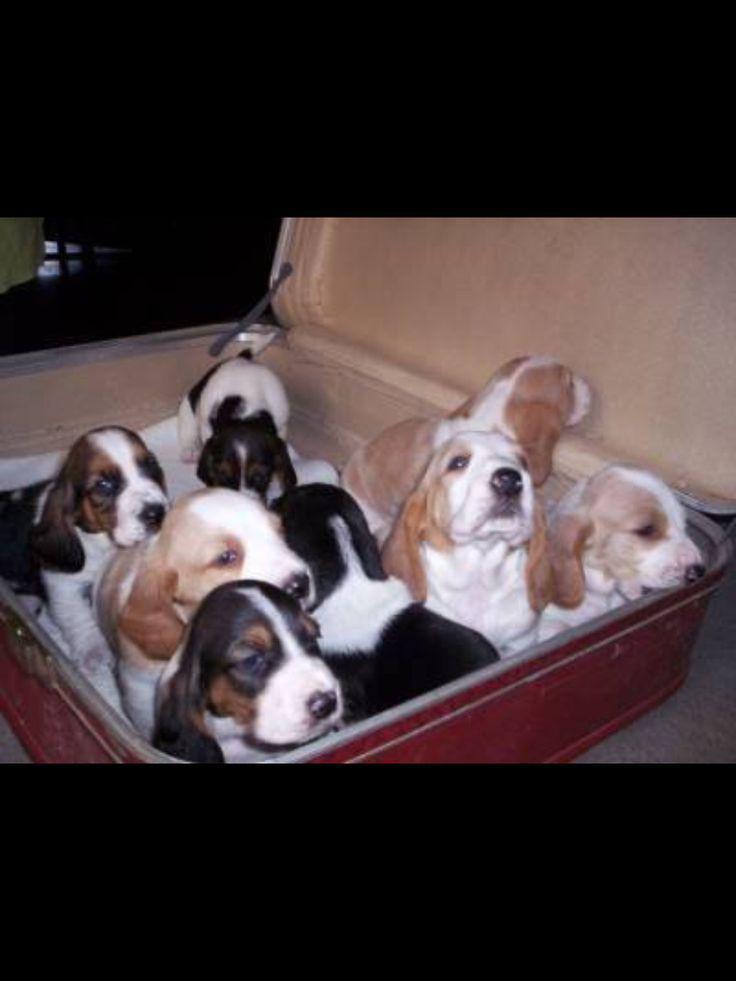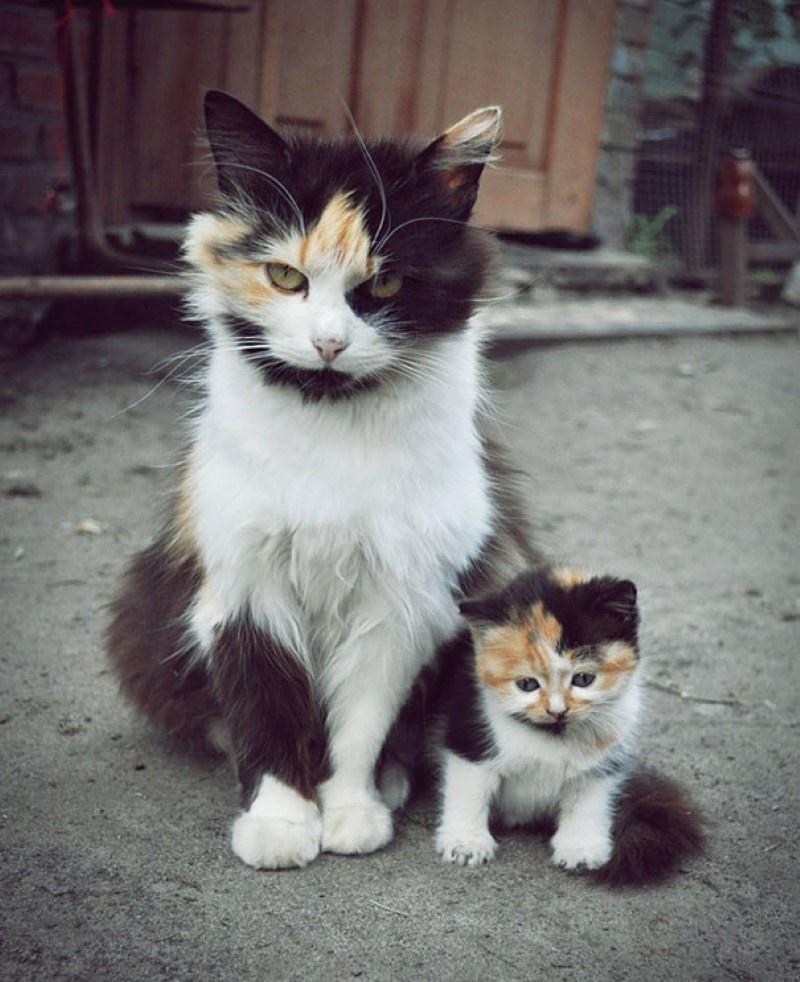The first image is the image on the left, the second image is the image on the right. Evaluate the accuracy of this statement regarding the images: "There is at least two dogs in the right image.". Is it true? Answer yes or no. No. 